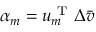<formula> <loc_0><loc_0><loc_500><loc_500>\alpha _ { m } = u _ { m } ^ { T } \Delta \bar { v }</formula> 